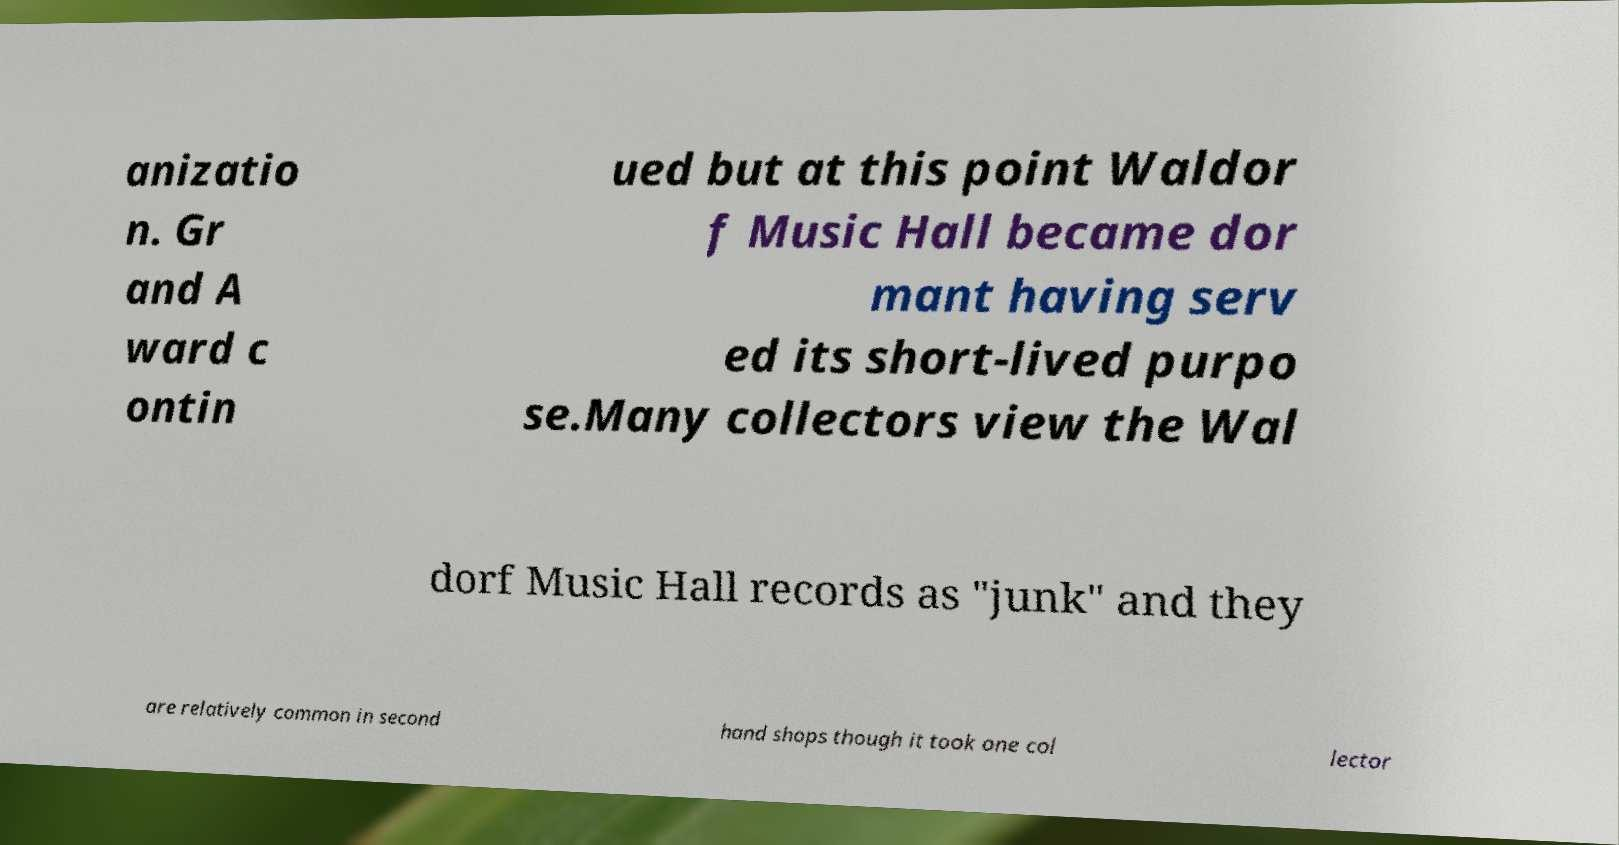Could you assist in decoding the text presented in this image and type it out clearly? anizatio n. Gr and A ward c ontin ued but at this point Waldor f Music Hall became dor mant having serv ed its short-lived purpo se.Many collectors view the Wal dorf Music Hall records as "junk" and they are relatively common in second hand shops though it took one col lector 